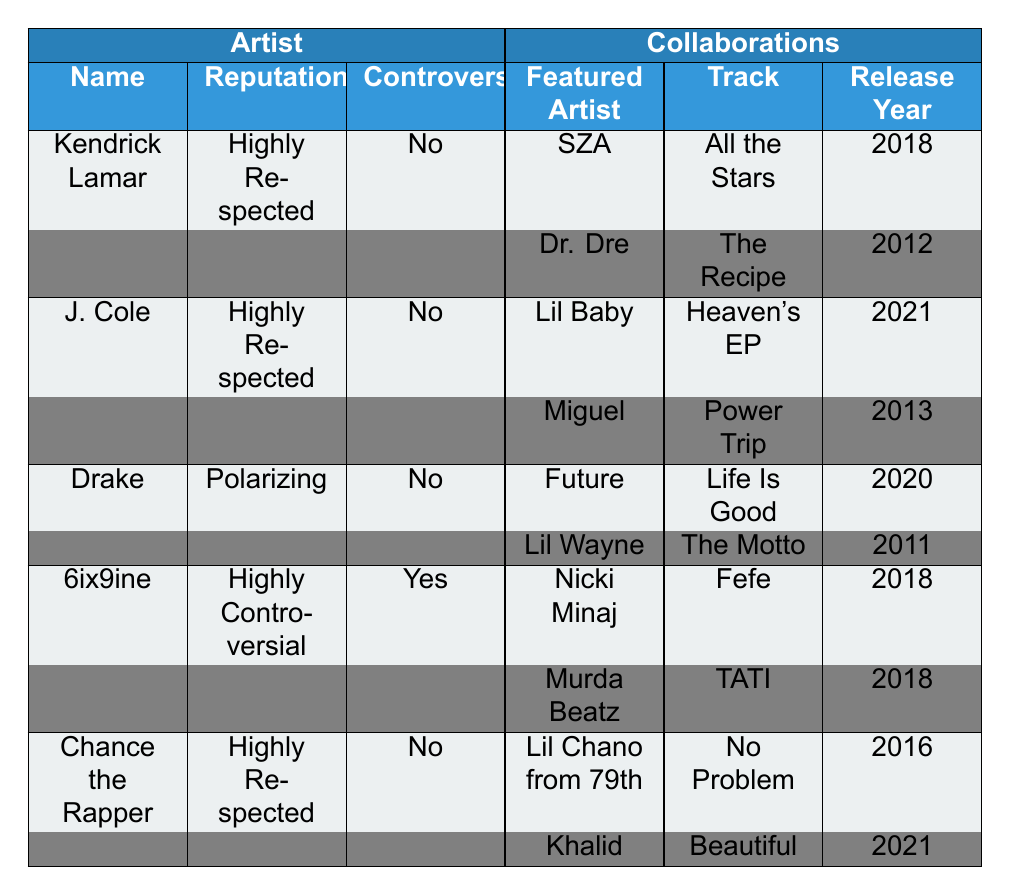What is the reputation of Kendrick Lamar? The table lists Kendrick Lamar's reputation under the "Reputation" column as "Highly Respected."
Answer: Highly Respected Which artist collaborated with Lil Baby? The table shows that J. Cole collaborated with Lil Baby in the track "Heaven's EP."
Answer: J. Cole How many collaborations does 6ix9ine have listed? The table shows two collaborations listed under 6ix9ine: "Fefe" with Nicki Minaj and "TATI" with Murda Beatz.
Answer: Two What reputation does Chance the Rapper have? According to the table, Chance the Rapper has a reputation marked as "Highly Respected."
Answer: Highly Respected Is 6ix9ine considered a controversial artist? The table indicates that 6ix9ine is categorized as "Highly Controversial."
Answer: Yes Which featured artist collaborated with Kendrick Lamar in 2018? The table shows SZA collaborated with Kendrick Lamar on the track "All the Stars," released in 2018.
Answer: SZA Are there any collaborations by artists with a "Highly Respected" reputation listed in 2021? Yes, J. Cole collaborated with Lil Baby in "Heaven's EP," and Chance the Rapper collaborated with Khalid in "Beautiful," both released in 2021.
Answer: Yes What tracks did Drake collaborate on with his featured artists? The table lists Drake's collaborations as "Life Is Good" with Future in 2020 and "The Motto" with Lil Wayne in 2011.
Answer: Life Is Good, The Motto How many artists in the table have a "Highly Respected" reputation? The table shows three artists with a "Highly Respected" reputation: Kendrick Lamar, J. Cole, and Chance the Rapper.
Answer: Three Which artist has collaborations with more than one featured artist? Kendrick Lamar, J. Cole, Drake, and Chance the Rapper each have two collaborations listed, while 6ix9ine has two as well.
Answer: All of them (Kendrick Lamar, J. Cole, Drake, Chance the Rapper, 6ix9ine) 